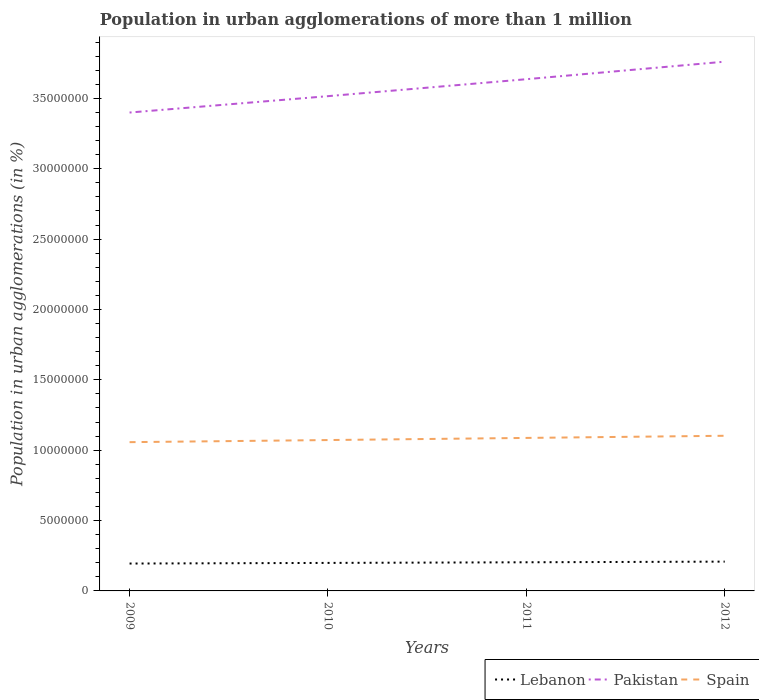How many different coloured lines are there?
Offer a very short reply. 3. Across all years, what is the maximum population in urban agglomerations in Pakistan?
Make the answer very short. 3.40e+07. In which year was the population in urban agglomerations in Lebanon maximum?
Provide a succinct answer. 2009. What is the total population in urban agglomerations in Pakistan in the graph?
Provide a succinct answer. -1.20e+06. What is the difference between the highest and the second highest population in urban agglomerations in Pakistan?
Keep it short and to the point. 3.61e+06. What is the difference between two consecutive major ticks on the Y-axis?
Offer a terse response. 5.00e+06. Where does the legend appear in the graph?
Ensure brevity in your answer.  Bottom right. How many legend labels are there?
Your response must be concise. 3. What is the title of the graph?
Offer a terse response. Population in urban agglomerations of more than 1 million. What is the label or title of the X-axis?
Ensure brevity in your answer.  Years. What is the label or title of the Y-axis?
Make the answer very short. Population in urban agglomerations (in %). What is the Population in urban agglomerations (in %) in Lebanon in 2009?
Your answer should be compact. 1.95e+06. What is the Population in urban agglomerations (in %) in Pakistan in 2009?
Keep it short and to the point. 3.40e+07. What is the Population in urban agglomerations (in %) of Spain in 2009?
Offer a very short reply. 1.06e+07. What is the Population in urban agglomerations (in %) of Lebanon in 2010?
Provide a short and direct response. 1.99e+06. What is the Population in urban agglomerations (in %) in Pakistan in 2010?
Provide a short and direct response. 3.52e+07. What is the Population in urban agglomerations (in %) in Spain in 2010?
Your response must be concise. 1.07e+07. What is the Population in urban agglomerations (in %) in Lebanon in 2011?
Give a very brief answer. 2.04e+06. What is the Population in urban agglomerations (in %) in Pakistan in 2011?
Keep it short and to the point. 3.64e+07. What is the Population in urban agglomerations (in %) in Spain in 2011?
Offer a terse response. 1.09e+07. What is the Population in urban agglomerations (in %) of Lebanon in 2012?
Make the answer very short. 2.08e+06. What is the Population in urban agglomerations (in %) in Pakistan in 2012?
Give a very brief answer. 3.76e+07. What is the Population in urban agglomerations (in %) of Spain in 2012?
Provide a short and direct response. 1.10e+07. Across all years, what is the maximum Population in urban agglomerations (in %) in Lebanon?
Provide a succinct answer. 2.08e+06. Across all years, what is the maximum Population in urban agglomerations (in %) in Pakistan?
Give a very brief answer. 3.76e+07. Across all years, what is the maximum Population in urban agglomerations (in %) in Spain?
Keep it short and to the point. 1.10e+07. Across all years, what is the minimum Population in urban agglomerations (in %) of Lebanon?
Provide a succinct answer. 1.95e+06. Across all years, what is the minimum Population in urban agglomerations (in %) in Pakistan?
Keep it short and to the point. 3.40e+07. Across all years, what is the minimum Population in urban agglomerations (in %) of Spain?
Your response must be concise. 1.06e+07. What is the total Population in urban agglomerations (in %) of Lebanon in the graph?
Give a very brief answer. 8.05e+06. What is the total Population in urban agglomerations (in %) of Pakistan in the graph?
Give a very brief answer. 1.43e+08. What is the total Population in urban agglomerations (in %) of Spain in the graph?
Your answer should be compact. 4.32e+07. What is the difference between the Population in urban agglomerations (in %) of Lebanon in 2009 and that in 2010?
Give a very brief answer. -4.45e+04. What is the difference between the Population in urban agglomerations (in %) in Pakistan in 2009 and that in 2010?
Offer a terse response. -1.16e+06. What is the difference between the Population in urban agglomerations (in %) of Spain in 2009 and that in 2010?
Keep it short and to the point. -1.49e+05. What is the difference between the Population in urban agglomerations (in %) in Lebanon in 2009 and that in 2011?
Your answer should be very brief. -9.01e+04. What is the difference between the Population in urban agglomerations (in %) of Pakistan in 2009 and that in 2011?
Offer a terse response. -2.37e+06. What is the difference between the Population in urban agglomerations (in %) of Spain in 2009 and that in 2011?
Offer a very short reply. -3.00e+05. What is the difference between the Population in urban agglomerations (in %) of Lebanon in 2009 and that in 2012?
Provide a succinct answer. -1.37e+05. What is the difference between the Population in urban agglomerations (in %) in Pakistan in 2009 and that in 2012?
Provide a succinct answer. -3.61e+06. What is the difference between the Population in urban agglomerations (in %) in Spain in 2009 and that in 2012?
Provide a succinct answer. -4.54e+05. What is the difference between the Population in urban agglomerations (in %) in Lebanon in 2010 and that in 2011?
Offer a terse response. -4.56e+04. What is the difference between the Population in urban agglomerations (in %) in Pakistan in 2010 and that in 2011?
Provide a succinct answer. -1.20e+06. What is the difference between the Population in urban agglomerations (in %) in Spain in 2010 and that in 2011?
Offer a terse response. -1.51e+05. What is the difference between the Population in urban agglomerations (in %) of Lebanon in 2010 and that in 2012?
Your answer should be compact. -9.22e+04. What is the difference between the Population in urban agglomerations (in %) in Pakistan in 2010 and that in 2012?
Offer a very short reply. -2.45e+06. What is the difference between the Population in urban agglomerations (in %) in Spain in 2010 and that in 2012?
Your answer should be compact. -3.05e+05. What is the difference between the Population in urban agglomerations (in %) of Lebanon in 2011 and that in 2012?
Offer a terse response. -4.66e+04. What is the difference between the Population in urban agglomerations (in %) in Pakistan in 2011 and that in 2012?
Your response must be concise. -1.25e+06. What is the difference between the Population in urban agglomerations (in %) of Spain in 2011 and that in 2012?
Provide a succinct answer. -1.54e+05. What is the difference between the Population in urban agglomerations (in %) of Lebanon in 2009 and the Population in urban agglomerations (in %) of Pakistan in 2010?
Offer a terse response. -3.32e+07. What is the difference between the Population in urban agglomerations (in %) in Lebanon in 2009 and the Population in urban agglomerations (in %) in Spain in 2010?
Give a very brief answer. -8.78e+06. What is the difference between the Population in urban agglomerations (in %) in Pakistan in 2009 and the Population in urban agglomerations (in %) in Spain in 2010?
Give a very brief answer. 2.33e+07. What is the difference between the Population in urban agglomerations (in %) of Lebanon in 2009 and the Population in urban agglomerations (in %) of Pakistan in 2011?
Keep it short and to the point. -3.44e+07. What is the difference between the Population in urban agglomerations (in %) in Lebanon in 2009 and the Population in urban agglomerations (in %) in Spain in 2011?
Ensure brevity in your answer.  -8.93e+06. What is the difference between the Population in urban agglomerations (in %) of Pakistan in 2009 and the Population in urban agglomerations (in %) of Spain in 2011?
Your response must be concise. 2.31e+07. What is the difference between the Population in urban agglomerations (in %) of Lebanon in 2009 and the Population in urban agglomerations (in %) of Pakistan in 2012?
Offer a terse response. -3.57e+07. What is the difference between the Population in urban agglomerations (in %) of Lebanon in 2009 and the Population in urban agglomerations (in %) of Spain in 2012?
Offer a very short reply. -9.08e+06. What is the difference between the Population in urban agglomerations (in %) in Pakistan in 2009 and the Population in urban agglomerations (in %) in Spain in 2012?
Your answer should be very brief. 2.30e+07. What is the difference between the Population in urban agglomerations (in %) in Lebanon in 2010 and the Population in urban agglomerations (in %) in Pakistan in 2011?
Offer a very short reply. -3.44e+07. What is the difference between the Population in urban agglomerations (in %) in Lebanon in 2010 and the Population in urban agglomerations (in %) in Spain in 2011?
Make the answer very short. -8.88e+06. What is the difference between the Population in urban agglomerations (in %) in Pakistan in 2010 and the Population in urban agglomerations (in %) in Spain in 2011?
Give a very brief answer. 2.43e+07. What is the difference between the Population in urban agglomerations (in %) in Lebanon in 2010 and the Population in urban agglomerations (in %) in Pakistan in 2012?
Your answer should be compact. -3.56e+07. What is the difference between the Population in urban agglomerations (in %) of Lebanon in 2010 and the Population in urban agglomerations (in %) of Spain in 2012?
Give a very brief answer. -9.04e+06. What is the difference between the Population in urban agglomerations (in %) of Pakistan in 2010 and the Population in urban agglomerations (in %) of Spain in 2012?
Keep it short and to the point. 2.41e+07. What is the difference between the Population in urban agglomerations (in %) of Lebanon in 2011 and the Population in urban agglomerations (in %) of Pakistan in 2012?
Your response must be concise. -3.56e+07. What is the difference between the Population in urban agglomerations (in %) in Lebanon in 2011 and the Population in urban agglomerations (in %) in Spain in 2012?
Offer a terse response. -8.99e+06. What is the difference between the Population in urban agglomerations (in %) in Pakistan in 2011 and the Population in urban agglomerations (in %) in Spain in 2012?
Provide a succinct answer. 2.53e+07. What is the average Population in urban agglomerations (in %) in Lebanon per year?
Make the answer very short. 2.01e+06. What is the average Population in urban agglomerations (in %) in Pakistan per year?
Offer a very short reply. 3.58e+07. What is the average Population in urban agglomerations (in %) in Spain per year?
Make the answer very short. 1.08e+07. In the year 2009, what is the difference between the Population in urban agglomerations (in %) of Lebanon and Population in urban agglomerations (in %) of Pakistan?
Your answer should be compact. -3.20e+07. In the year 2009, what is the difference between the Population in urban agglomerations (in %) in Lebanon and Population in urban agglomerations (in %) in Spain?
Offer a terse response. -8.63e+06. In the year 2009, what is the difference between the Population in urban agglomerations (in %) of Pakistan and Population in urban agglomerations (in %) of Spain?
Offer a very short reply. 2.34e+07. In the year 2010, what is the difference between the Population in urban agglomerations (in %) of Lebanon and Population in urban agglomerations (in %) of Pakistan?
Your response must be concise. -3.32e+07. In the year 2010, what is the difference between the Population in urban agglomerations (in %) of Lebanon and Population in urban agglomerations (in %) of Spain?
Provide a short and direct response. -8.73e+06. In the year 2010, what is the difference between the Population in urban agglomerations (in %) in Pakistan and Population in urban agglomerations (in %) in Spain?
Ensure brevity in your answer.  2.44e+07. In the year 2011, what is the difference between the Population in urban agglomerations (in %) in Lebanon and Population in urban agglomerations (in %) in Pakistan?
Your answer should be compact. -3.43e+07. In the year 2011, what is the difference between the Population in urban agglomerations (in %) in Lebanon and Population in urban agglomerations (in %) in Spain?
Provide a short and direct response. -8.84e+06. In the year 2011, what is the difference between the Population in urban agglomerations (in %) in Pakistan and Population in urban agglomerations (in %) in Spain?
Your answer should be very brief. 2.55e+07. In the year 2012, what is the difference between the Population in urban agglomerations (in %) in Lebanon and Population in urban agglomerations (in %) in Pakistan?
Give a very brief answer. -3.55e+07. In the year 2012, what is the difference between the Population in urban agglomerations (in %) in Lebanon and Population in urban agglomerations (in %) in Spain?
Keep it short and to the point. -8.94e+06. In the year 2012, what is the difference between the Population in urban agglomerations (in %) of Pakistan and Population in urban agglomerations (in %) of Spain?
Keep it short and to the point. 2.66e+07. What is the ratio of the Population in urban agglomerations (in %) in Lebanon in 2009 to that in 2010?
Provide a short and direct response. 0.98. What is the ratio of the Population in urban agglomerations (in %) of Pakistan in 2009 to that in 2010?
Offer a terse response. 0.97. What is the ratio of the Population in urban agglomerations (in %) of Spain in 2009 to that in 2010?
Give a very brief answer. 0.99. What is the ratio of the Population in urban agglomerations (in %) in Lebanon in 2009 to that in 2011?
Provide a short and direct response. 0.96. What is the ratio of the Population in urban agglomerations (in %) in Pakistan in 2009 to that in 2011?
Give a very brief answer. 0.93. What is the ratio of the Population in urban agglomerations (in %) in Spain in 2009 to that in 2011?
Your answer should be compact. 0.97. What is the ratio of the Population in urban agglomerations (in %) of Lebanon in 2009 to that in 2012?
Give a very brief answer. 0.93. What is the ratio of the Population in urban agglomerations (in %) in Pakistan in 2009 to that in 2012?
Provide a short and direct response. 0.9. What is the ratio of the Population in urban agglomerations (in %) in Spain in 2009 to that in 2012?
Your answer should be very brief. 0.96. What is the ratio of the Population in urban agglomerations (in %) in Lebanon in 2010 to that in 2011?
Your answer should be compact. 0.98. What is the ratio of the Population in urban agglomerations (in %) in Pakistan in 2010 to that in 2011?
Make the answer very short. 0.97. What is the ratio of the Population in urban agglomerations (in %) of Spain in 2010 to that in 2011?
Offer a very short reply. 0.99. What is the ratio of the Population in urban agglomerations (in %) in Lebanon in 2010 to that in 2012?
Your answer should be very brief. 0.96. What is the ratio of the Population in urban agglomerations (in %) of Pakistan in 2010 to that in 2012?
Give a very brief answer. 0.93. What is the ratio of the Population in urban agglomerations (in %) of Spain in 2010 to that in 2012?
Your response must be concise. 0.97. What is the ratio of the Population in urban agglomerations (in %) in Lebanon in 2011 to that in 2012?
Your response must be concise. 0.98. What is the ratio of the Population in urban agglomerations (in %) in Pakistan in 2011 to that in 2012?
Your response must be concise. 0.97. What is the ratio of the Population in urban agglomerations (in %) of Spain in 2011 to that in 2012?
Your answer should be compact. 0.99. What is the difference between the highest and the second highest Population in urban agglomerations (in %) in Lebanon?
Provide a short and direct response. 4.66e+04. What is the difference between the highest and the second highest Population in urban agglomerations (in %) of Pakistan?
Your response must be concise. 1.25e+06. What is the difference between the highest and the second highest Population in urban agglomerations (in %) in Spain?
Provide a short and direct response. 1.54e+05. What is the difference between the highest and the lowest Population in urban agglomerations (in %) of Lebanon?
Offer a terse response. 1.37e+05. What is the difference between the highest and the lowest Population in urban agglomerations (in %) in Pakistan?
Keep it short and to the point. 3.61e+06. What is the difference between the highest and the lowest Population in urban agglomerations (in %) in Spain?
Offer a terse response. 4.54e+05. 